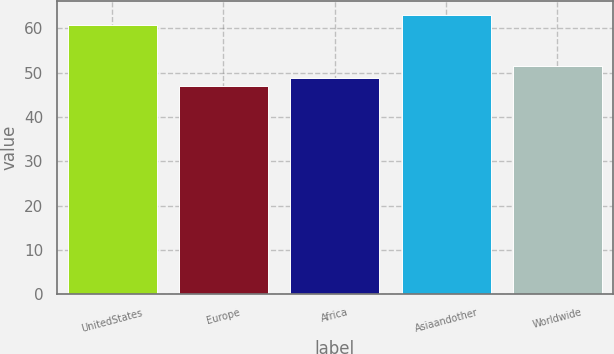Convert chart. <chart><loc_0><loc_0><loc_500><loc_500><bar_chart><fcel>UnitedStates<fcel>Europe<fcel>Africa<fcel>Asiaandother<fcel>Worldwide<nl><fcel>60.67<fcel>47.02<fcel>48.91<fcel>63.01<fcel>51.62<nl></chart> 